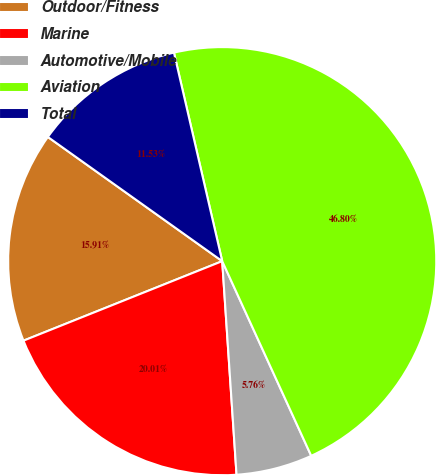<chart> <loc_0><loc_0><loc_500><loc_500><pie_chart><fcel>Outdoor/Fitness<fcel>Marine<fcel>Automotive/Mobile<fcel>Aviation<fcel>Total<nl><fcel>15.91%<fcel>20.01%<fcel>5.76%<fcel>46.8%<fcel>11.53%<nl></chart> 